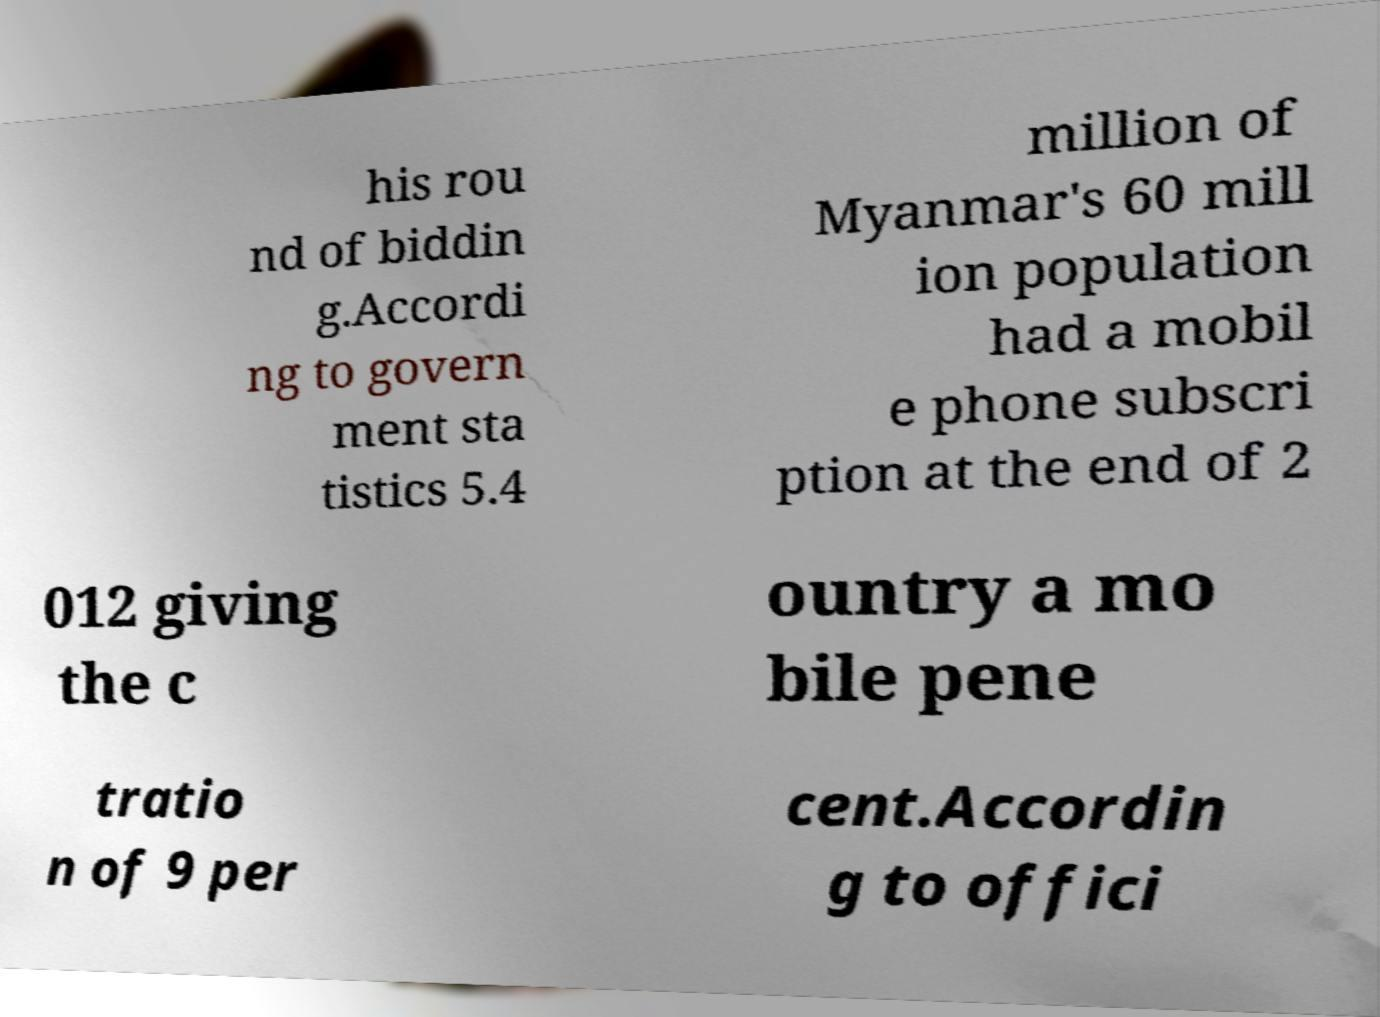Could you extract and type out the text from this image? his rou nd of biddin g.Accordi ng to govern ment sta tistics 5.4 million of Myanmar's 60 mill ion population had a mobil e phone subscri ption at the end of 2 012 giving the c ountry a mo bile pene tratio n of 9 per cent.Accordin g to offici 